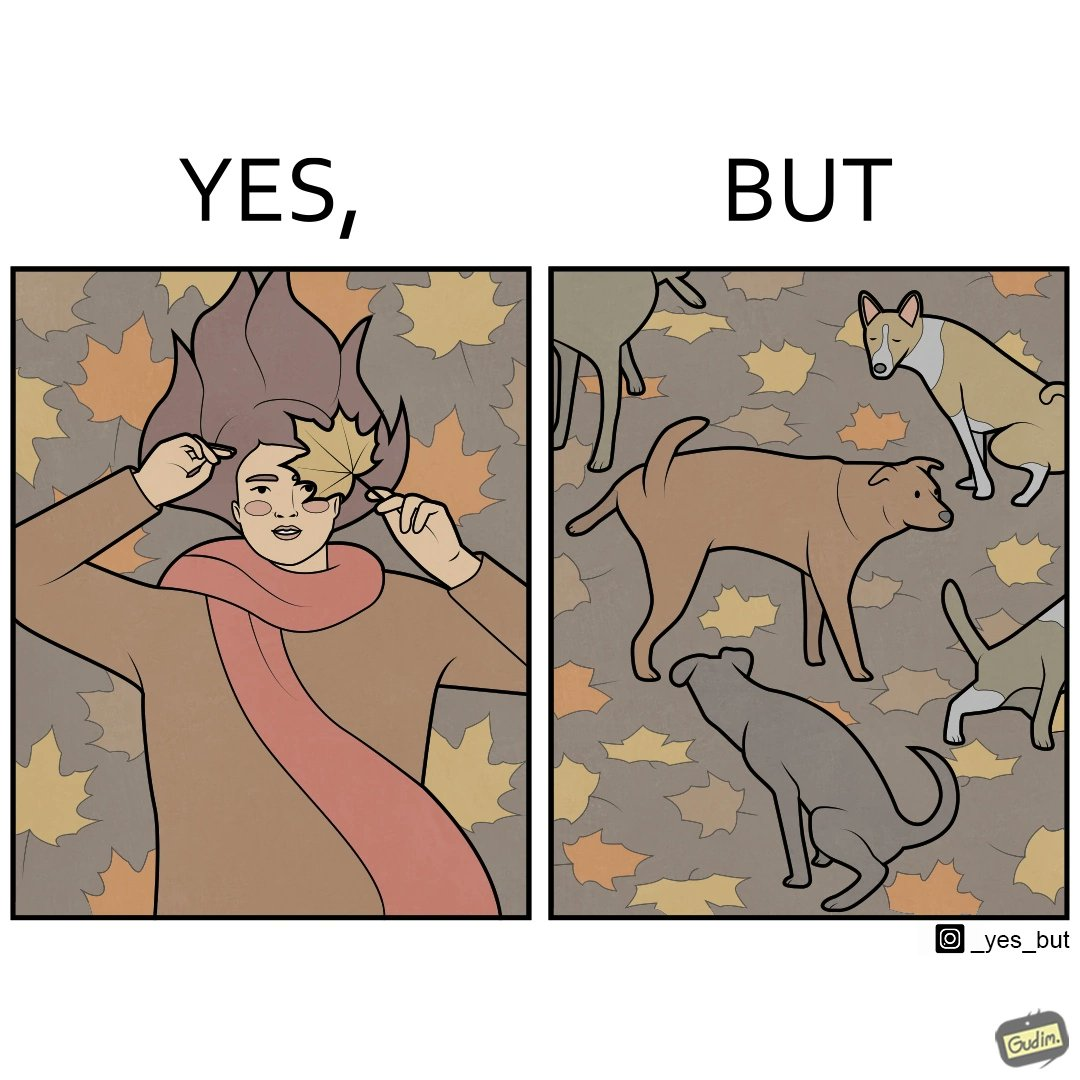Describe the contrast between the left and right parts of this image. In the left part of the image: It is a woman holding a leaf over half of her face for a good photo In the right part of the image: It is a few dogs defecating and urinating over leaves 